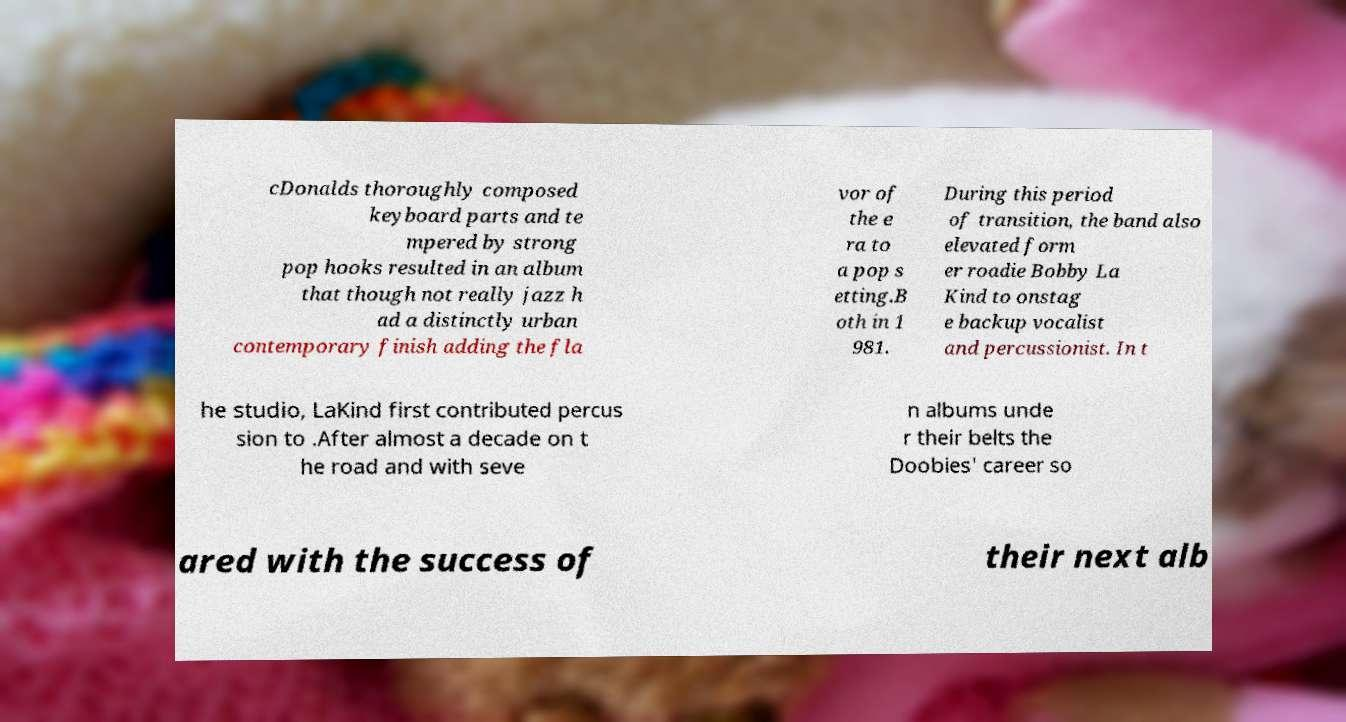Could you assist in decoding the text presented in this image and type it out clearly? cDonalds thoroughly composed keyboard parts and te mpered by strong pop hooks resulted in an album that though not really jazz h ad a distinctly urban contemporary finish adding the fla vor of the e ra to a pop s etting.B oth in 1 981. During this period of transition, the band also elevated form er roadie Bobby La Kind to onstag e backup vocalist and percussionist. In t he studio, LaKind first contributed percus sion to .After almost a decade on t he road and with seve n albums unde r their belts the Doobies' career so ared with the success of their next alb 